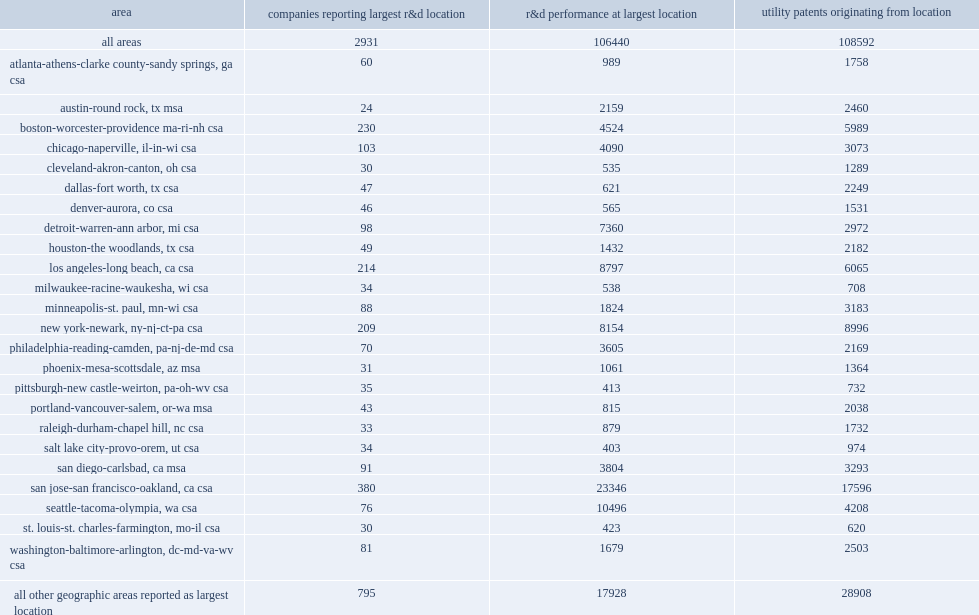Could you help me parse every detail presented in this table? {'header': ['area', 'companies reporting largest r&d location', 'r&d performance at largest location', 'utility patents originating from location'], 'rows': [['all areas', '2931', '106440', '108592'], ['atlanta-athens-clarke county-sandy springs, ga csa', '60', '989', '1758'], ['austin-round rock, tx msa', '24', '2159', '2460'], ['boston-worcester-providence ma-ri-nh csa', '230', '4524', '5989'], ['chicago-naperville, il-in-wi csa', '103', '4090', '3073'], ['cleveland-akron-canton, oh csa', '30', '535', '1289'], ['dallas-fort worth, tx csa', '47', '621', '2249'], ['denver-aurora, co csa', '46', '565', '1531'], ['detroit-warren-ann arbor, mi csa', '98', '7360', '2972'], ['houston-the woodlands, tx csa', '49', '1432', '2182'], ['los angeles-long beach, ca csa', '214', '8797', '6065'], ['milwaukee-racine-waukesha, wi csa', '34', '538', '708'], ['minneapolis-st. paul, mn-wi csa', '88', '1824', '3183'], ['new york-newark, ny-nj-ct-pa csa', '209', '8154', '8996'], ['philadelphia-reading-camden, pa-nj-de-md csa', '70', '3605', '2169'], ['phoenix-mesa-scottsdale, az msa', '31', '1061', '1364'], ['pittsburgh-new castle-weirton, pa-oh-wv csa', '35', '413', '732'], ['portland-vancouver-salem, or-wa msa', '43', '815', '2038'], ['raleigh-durham-chapel hill, nc csa', '33', '879', '1732'], ['salt lake city-provo-orem, ut csa', '34', '403', '974'], ['san diego-carlsbad, ca msa', '91', '3804', '3293'], ['san jose-san francisco-oakland, ca csa', '380', '23346', '17596'], ['seattle-tacoma-olympia, wa csa', '76', '10496', '4208'], ['st. louis-st. charles-farmington, mo-il csa', '30', '423', '620'], ['washington-baltimore-arlington, dc-md-va-wv csa', '81', '1679', '2503'], ['all other geographic areas reported as largest location', '795', '17928', '28908']]} How many companies did the 10 most frequently reported combined statistical areas (csas) or metropolitan statistical areas (msas) account for reporting their largest r&d location? 2931.0. How many million dollars did the 2,931 large-r&d companies perform of r&d at their primary r&d location alone? 106440.0. 